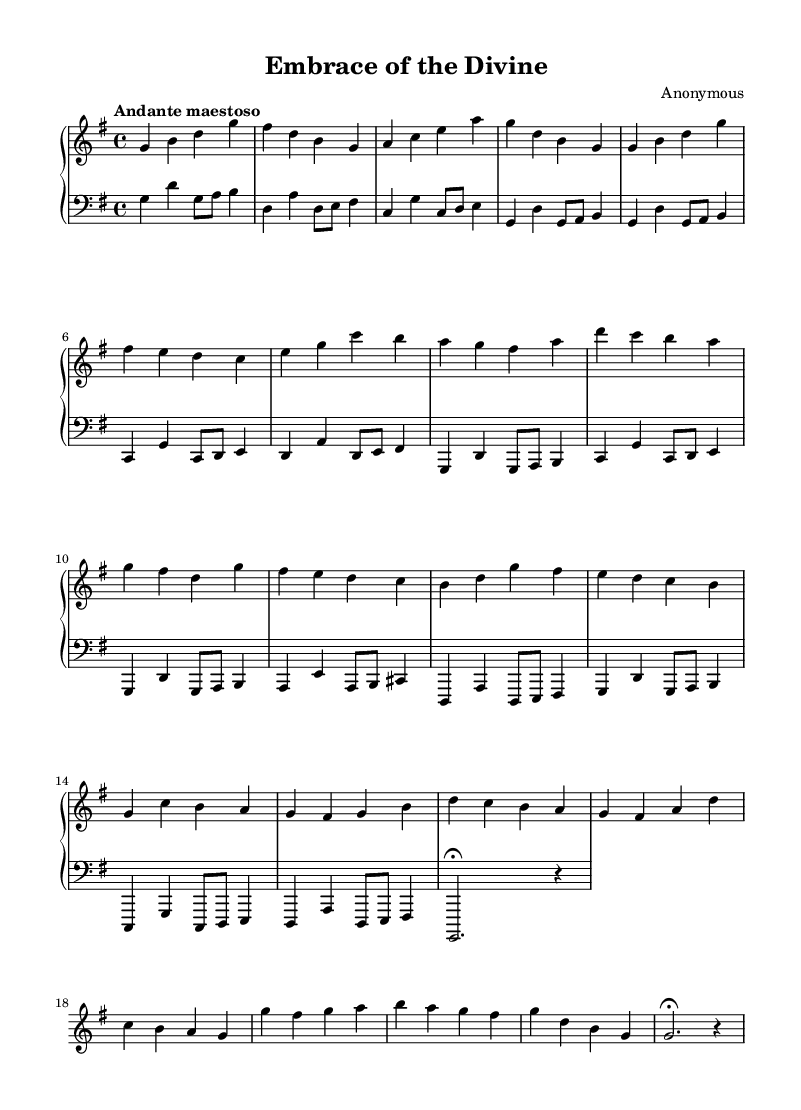What is the key signature of this music? The key signature is G major, which has one sharp (F#). This is determined by looking at the beginning of the staff where the sharps are indicated.
Answer: G major What is the time signature of the piece? The time signature is 4/4, which can be found at the beginning of the staff where it shows the beats per measure and note value. This indicates that there are four beats in each measure, and a quarter note gets one beat.
Answer: 4/4 What is the tempo marking given in the sheet music? The tempo marking is "Andante maestoso," which specifies the performance speed and style. This can be found at the beginning of the music and indicates a moderate and dignified pace.
Answer: Andante maestoso How many measures are there in the introduction section? The introduction section consists of 4 measures. By counting the vertical lines that separate the measures in the music, we can confirm this total.
Answer: 4 measures What is the form of the piece based on its thematic structure? The piece follows a binary form, as it presents two distinct themes (Theme A and Theme B) that are showcased and interspersed. This can be deduced from the arrangement of the themes throughout the composition in separate sections.
Answer: Binary form What is the significance of the dynamics indicated in the left hand? The left hand part has no specified dynamics; this suggests a more supportive role in the accompaniment, typical of Baroque music where the focus is often on the melodic right hand. The absence of markings can indicate a consistent volume throughout.
Answer: Supportive role What compositional technique is used in the left hand's pattern? The left hand employs a broken chord technique, evident in how the pitches are spread out instead of played simultaneously. This technique is characteristic of Baroque music, providing harmonic support while still allowing for melodic clarity.
Answer: Broken chord 